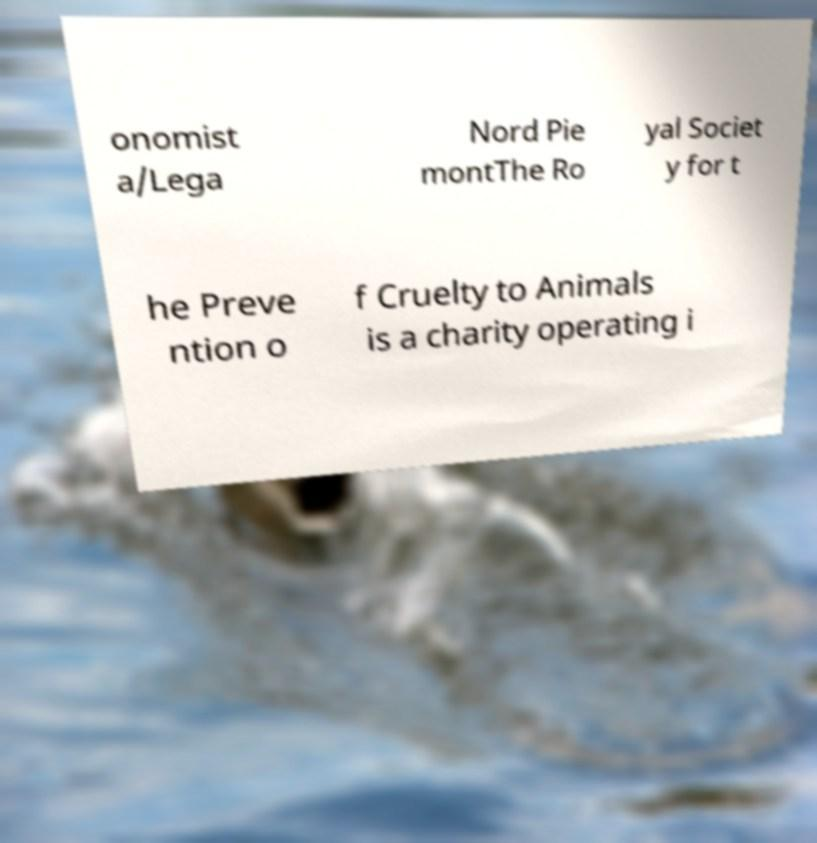Can you accurately transcribe the text from the provided image for me? onomist a/Lega Nord Pie montThe Ro yal Societ y for t he Preve ntion o f Cruelty to Animals is a charity operating i 